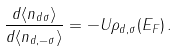<formula> <loc_0><loc_0><loc_500><loc_500>\frac { d \langle n _ { d \sigma } \rangle } { d \langle n _ { d , - \sigma } \rangle } = - U \rho _ { d , \sigma } ( E _ { F } ) \, .</formula> 